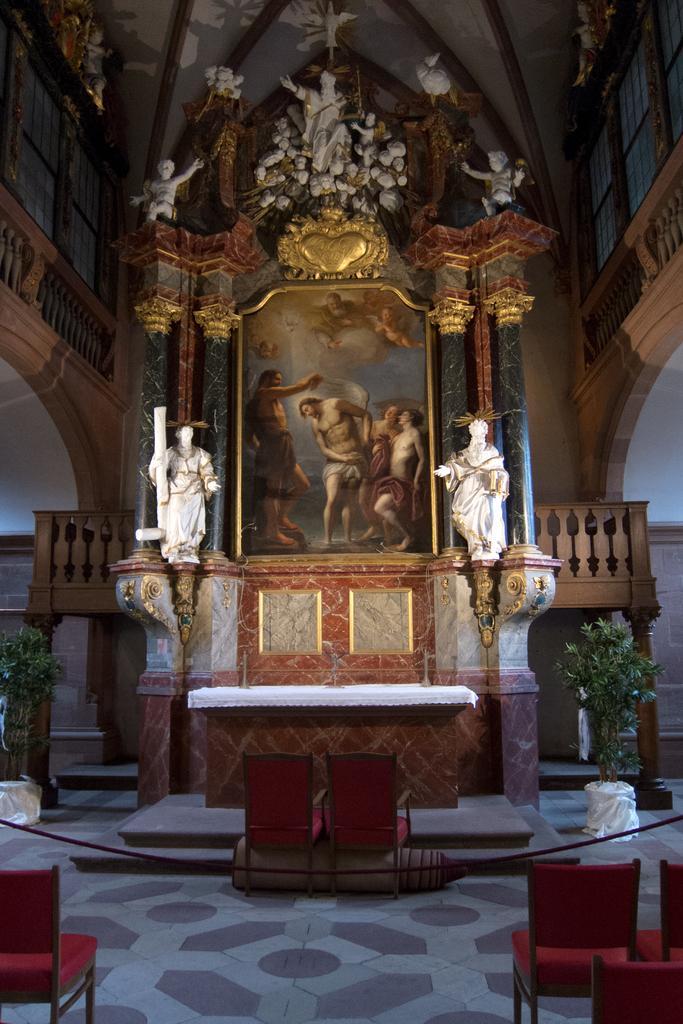In one or two sentences, can you explain what this image depicts? In this image we see a table, here are the chairs on the ground, here is the plant, here is the photo frame, here are the sculptures, here is the wall. 